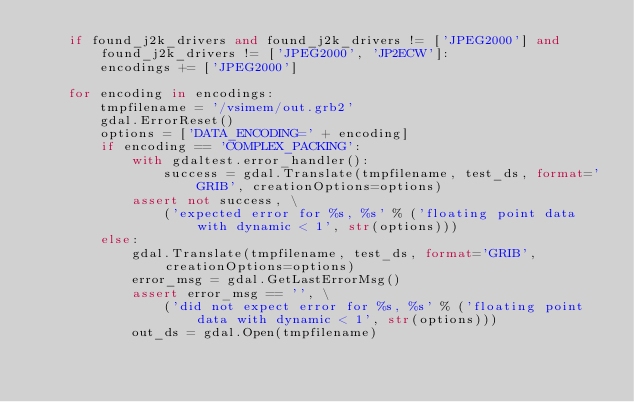<code> <loc_0><loc_0><loc_500><loc_500><_Python_>    if found_j2k_drivers and found_j2k_drivers != ['JPEG2000'] and found_j2k_drivers != ['JPEG2000', 'JP2ECW']:
        encodings += ['JPEG2000']

    for encoding in encodings:
        tmpfilename = '/vsimem/out.grb2'
        gdal.ErrorReset()
        options = ['DATA_ENCODING=' + encoding]
        if encoding == 'COMPLEX_PACKING':
            with gdaltest.error_handler():
                success = gdal.Translate(tmpfilename, test_ds, format='GRIB', creationOptions=options)
            assert not success, \
                ('expected error for %s, %s' % ('floating point data with dynamic < 1', str(options)))
        else:
            gdal.Translate(tmpfilename, test_ds, format='GRIB', creationOptions=options)
            error_msg = gdal.GetLastErrorMsg()
            assert error_msg == '', \
                ('did not expect error for %s, %s' % ('floating point data with dynamic < 1', str(options)))
            out_ds = gdal.Open(tmpfilename)</code> 